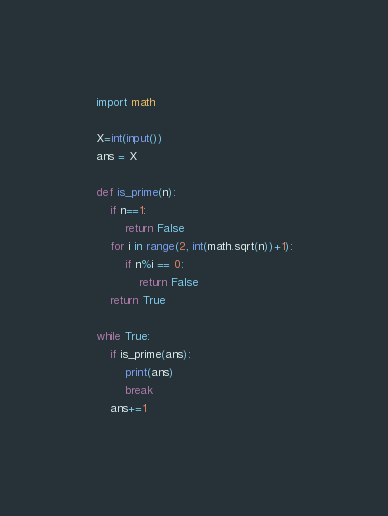Convert code to text. <code><loc_0><loc_0><loc_500><loc_500><_Python_>import math
 
X=int(input())
ans = X
 
def is_prime(n):
    if n==1:
        return False
    for i in range(2, int(math.sqrt(n))+1):
        if n%i == 0:
            return False
    return True

while True:
    if is_prime(ans):
        print(ans)
        break
    ans+=1</code> 